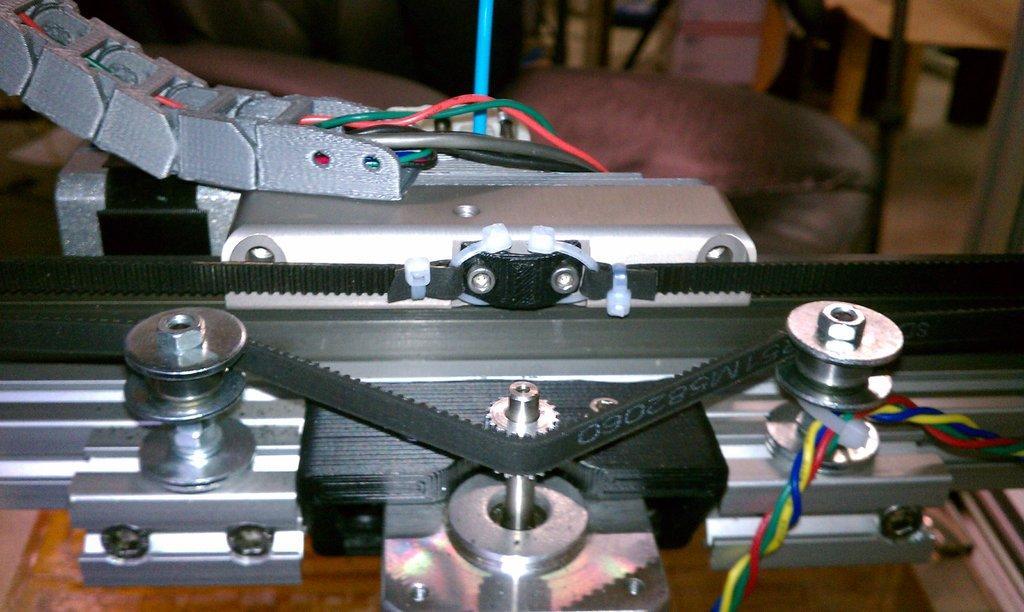Please provide a concise description of this image. In this image we can see a machine. Behind the machine we can see the chairs. In the top right, we can see a wooden object. 